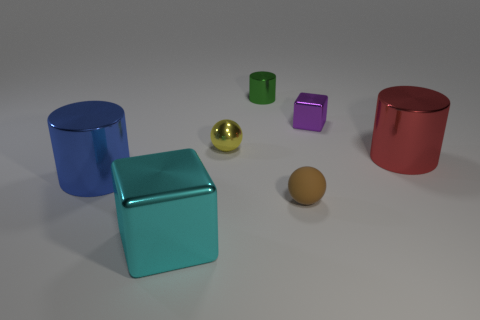There is a metallic block to the right of the ball in front of the large object that is right of the big cyan metallic block; what is its size?
Provide a short and direct response. Small. There is a metallic cube in front of the large red thing; what is its size?
Your answer should be compact. Large. The large cyan thing that is the same material as the purple object is what shape?
Offer a terse response. Cube. Do the cube that is behind the small yellow metal sphere and the red object have the same material?
Your answer should be compact. Yes. How many other things are there of the same material as the tiny cube?
Keep it short and to the point. 5. What number of things are large things that are behind the brown matte ball or cubes in front of the tiny metallic cube?
Your answer should be compact. 3. There is a large metal object that is in front of the blue metallic cylinder; is its shape the same as the tiny metallic object on the right side of the brown object?
Make the answer very short. Yes. There is a purple thing that is the same size as the yellow metal object; what is its shape?
Your answer should be very brief. Cube. What number of metal things are large cylinders or big blue balls?
Your response must be concise. 2. Does the tiny object that is on the right side of the small rubber thing have the same material as the thing that is in front of the brown matte ball?
Offer a very short reply. Yes. 